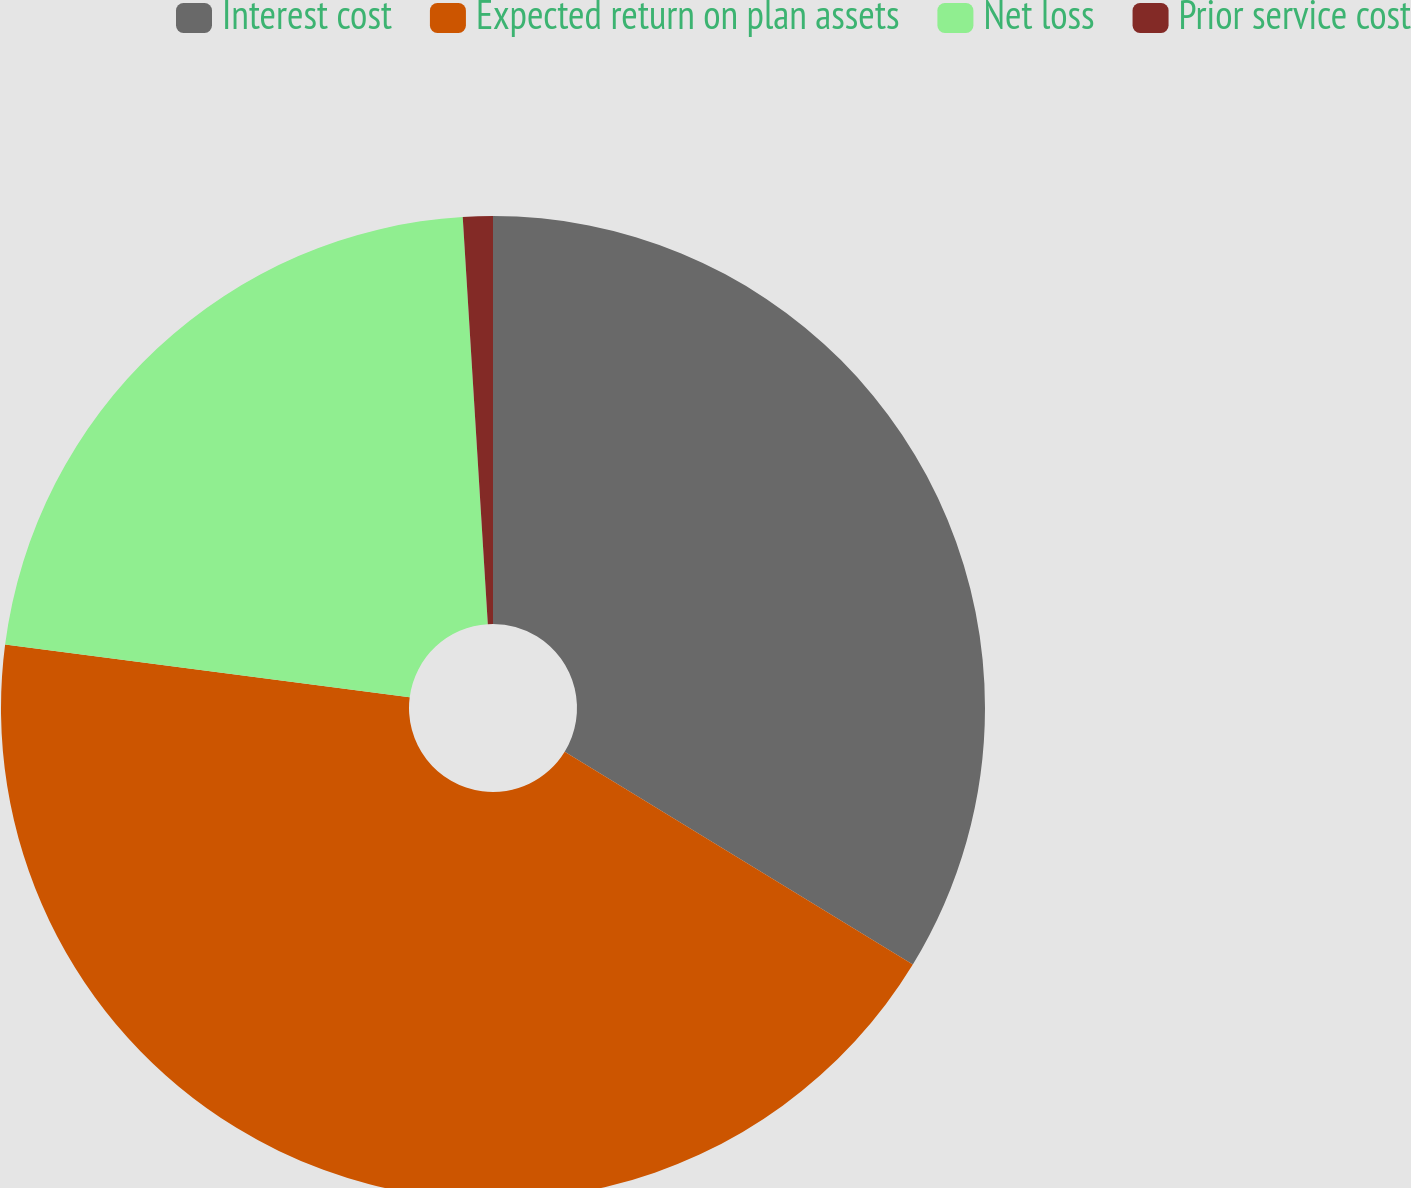Convert chart to OTSL. <chart><loc_0><loc_0><loc_500><loc_500><pie_chart><fcel>Interest cost<fcel>Expected return on plan assets<fcel>Net loss<fcel>Prior service cost<nl><fcel>33.73%<fcel>43.33%<fcel>21.96%<fcel>0.98%<nl></chart> 